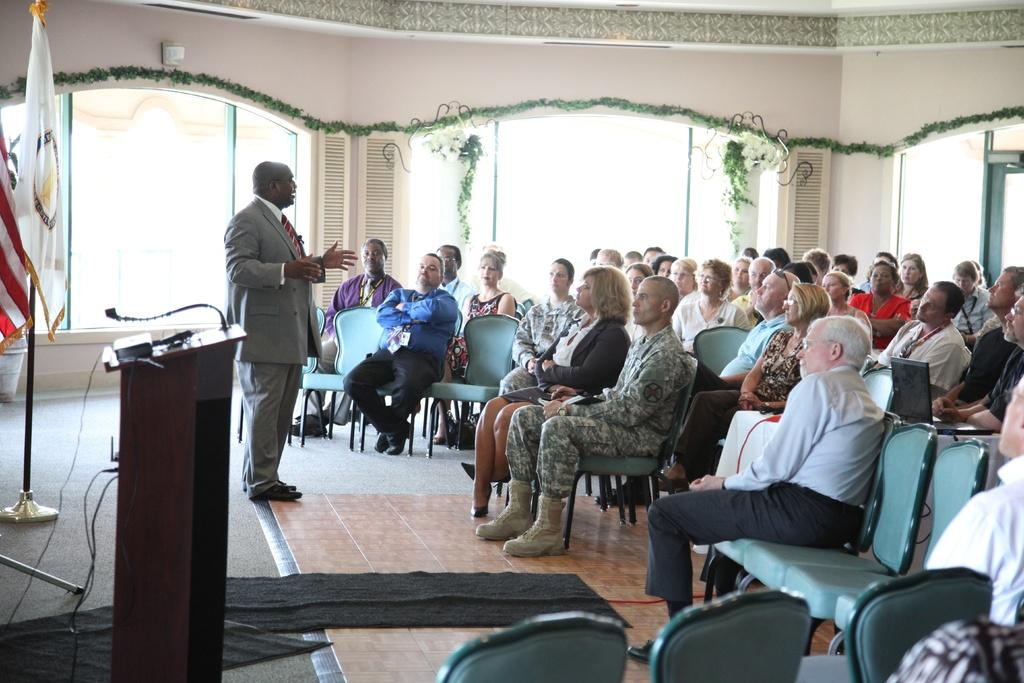What are the people in the image doing? The people in the image are sitting. What is the man in the image doing? The man in the image is standing. What can be seen in the background of the image? There are flags, a mic stand, and decor on the wall in the background of the image. How many feathers can be seen on the man's hat in the image? There are no feathers visible on the man's hat in the image. What type of spiders are crawling on the decor on the wall in the image? There are no spiders present in the image; the decor on the wall does not include any spiders. 